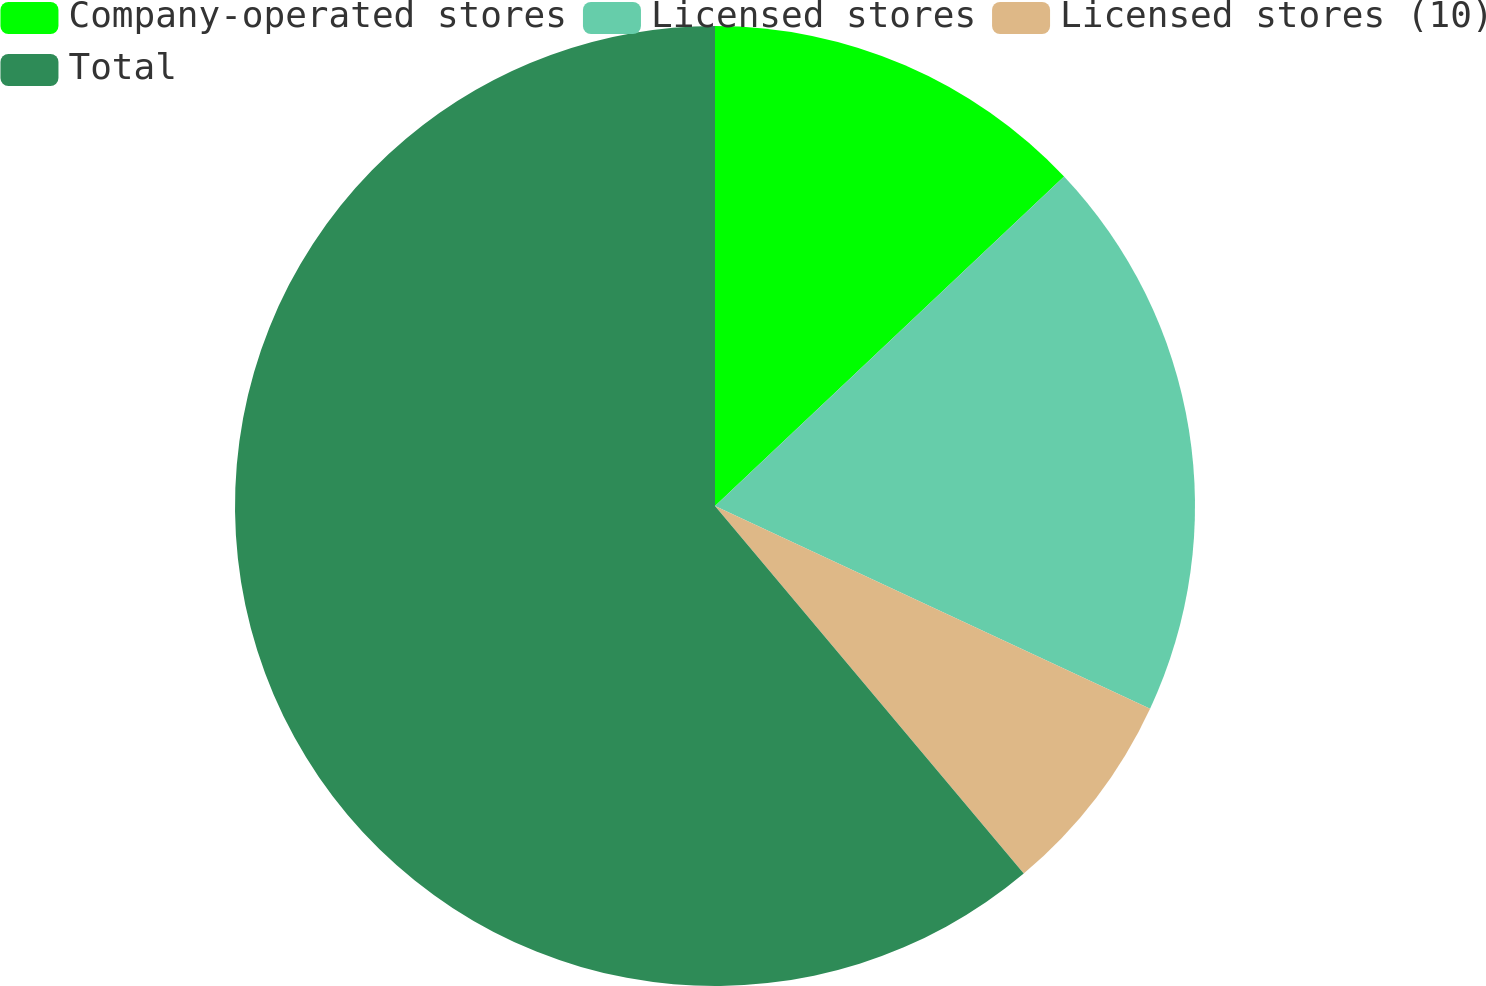Convert chart to OTSL. <chart><loc_0><loc_0><loc_500><loc_500><pie_chart><fcel>Company-operated stores<fcel>Licensed stores<fcel>Licensed stores (10)<fcel>Total<nl><fcel>12.96%<fcel>18.98%<fcel>6.94%<fcel>61.12%<nl></chart> 